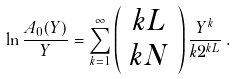Convert formula to latex. <formula><loc_0><loc_0><loc_500><loc_500>\ln \frac { A _ { 0 } ( Y ) } { Y } = \sum _ { k = 1 } ^ { \infty } \left ( \begin{array} { c } k L \\ k N \end{array} \right ) \frac { Y ^ { k } } { k 2 ^ { k L } } \, .</formula> 